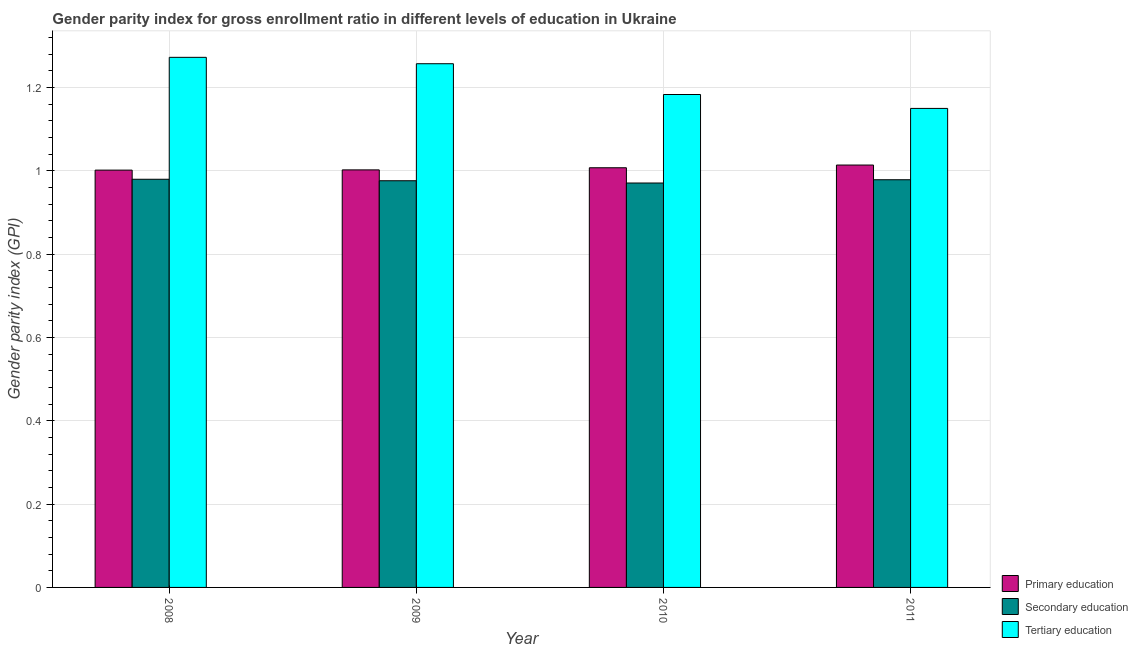How many groups of bars are there?
Your answer should be very brief. 4. Are the number of bars per tick equal to the number of legend labels?
Offer a very short reply. Yes. What is the label of the 2nd group of bars from the left?
Provide a succinct answer. 2009. In how many cases, is the number of bars for a given year not equal to the number of legend labels?
Offer a very short reply. 0. What is the gender parity index in primary education in 2009?
Give a very brief answer. 1. Across all years, what is the maximum gender parity index in secondary education?
Keep it short and to the point. 0.98. Across all years, what is the minimum gender parity index in secondary education?
Give a very brief answer. 0.97. What is the total gender parity index in secondary education in the graph?
Provide a succinct answer. 3.91. What is the difference between the gender parity index in primary education in 2009 and that in 2010?
Provide a succinct answer. -0.01. What is the difference between the gender parity index in secondary education in 2011 and the gender parity index in tertiary education in 2009?
Your answer should be compact. 0. What is the average gender parity index in primary education per year?
Make the answer very short. 1.01. In how many years, is the gender parity index in primary education greater than 1.2400000000000002?
Offer a very short reply. 0. What is the ratio of the gender parity index in primary education in 2008 to that in 2009?
Your answer should be compact. 1. Is the difference between the gender parity index in tertiary education in 2009 and 2010 greater than the difference between the gender parity index in primary education in 2009 and 2010?
Provide a succinct answer. No. What is the difference between the highest and the second highest gender parity index in tertiary education?
Give a very brief answer. 0.02. What is the difference between the highest and the lowest gender parity index in tertiary education?
Offer a very short reply. 0.12. In how many years, is the gender parity index in secondary education greater than the average gender parity index in secondary education taken over all years?
Make the answer very short. 2. Is the sum of the gender parity index in secondary education in 2008 and 2011 greater than the maximum gender parity index in tertiary education across all years?
Offer a very short reply. Yes. What does the 2nd bar from the left in 2008 represents?
Offer a terse response. Secondary education. What does the 3rd bar from the right in 2011 represents?
Offer a terse response. Primary education. Is it the case that in every year, the sum of the gender parity index in primary education and gender parity index in secondary education is greater than the gender parity index in tertiary education?
Your answer should be very brief. Yes. How many bars are there?
Your answer should be very brief. 12. How many years are there in the graph?
Your response must be concise. 4. How many legend labels are there?
Give a very brief answer. 3. What is the title of the graph?
Ensure brevity in your answer.  Gender parity index for gross enrollment ratio in different levels of education in Ukraine. Does "Machinery" appear as one of the legend labels in the graph?
Give a very brief answer. No. What is the label or title of the Y-axis?
Offer a very short reply. Gender parity index (GPI). What is the Gender parity index (GPI) of Primary education in 2008?
Your answer should be very brief. 1. What is the Gender parity index (GPI) in Secondary education in 2008?
Provide a short and direct response. 0.98. What is the Gender parity index (GPI) of Tertiary education in 2008?
Your response must be concise. 1.27. What is the Gender parity index (GPI) of Primary education in 2009?
Make the answer very short. 1. What is the Gender parity index (GPI) of Secondary education in 2009?
Offer a very short reply. 0.98. What is the Gender parity index (GPI) in Tertiary education in 2009?
Make the answer very short. 1.26. What is the Gender parity index (GPI) in Primary education in 2010?
Make the answer very short. 1.01. What is the Gender parity index (GPI) of Secondary education in 2010?
Provide a succinct answer. 0.97. What is the Gender parity index (GPI) in Tertiary education in 2010?
Provide a succinct answer. 1.18. What is the Gender parity index (GPI) of Primary education in 2011?
Offer a very short reply. 1.01. What is the Gender parity index (GPI) of Secondary education in 2011?
Provide a short and direct response. 0.98. What is the Gender parity index (GPI) in Tertiary education in 2011?
Keep it short and to the point. 1.15. Across all years, what is the maximum Gender parity index (GPI) of Primary education?
Make the answer very short. 1.01. Across all years, what is the maximum Gender parity index (GPI) in Secondary education?
Keep it short and to the point. 0.98. Across all years, what is the maximum Gender parity index (GPI) of Tertiary education?
Keep it short and to the point. 1.27. Across all years, what is the minimum Gender parity index (GPI) in Primary education?
Offer a very short reply. 1. Across all years, what is the minimum Gender parity index (GPI) of Secondary education?
Provide a short and direct response. 0.97. Across all years, what is the minimum Gender parity index (GPI) in Tertiary education?
Ensure brevity in your answer.  1.15. What is the total Gender parity index (GPI) in Primary education in the graph?
Keep it short and to the point. 4.03. What is the total Gender parity index (GPI) in Secondary education in the graph?
Offer a terse response. 3.91. What is the total Gender parity index (GPI) in Tertiary education in the graph?
Ensure brevity in your answer.  4.86. What is the difference between the Gender parity index (GPI) of Primary education in 2008 and that in 2009?
Offer a terse response. -0. What is the difference between the Gender parity index (GPI) of Secondary education in 2008 and that in 2009?
Your answer should be compact. 0. What is the difference between the Gender parity index (GPI) of Tertiary education in 2008 and that in 2009?
Ensure brevity in your answer.  0.02. What is the difference between the Gender parity index (GPI) of Primary education in 2008 and that in 2010?
Keep it short and to the point. -0.01. What is the difference between the Gender parity index (GPI) in Secondary education in 2008 and that in 2010?
Provide a succinct answer. 0.01. What is the difference between the Gender parity index (GPI) in Tertiary education in 2008 and that in 2010?
Make the answer very short. 0.09. What is the difference between the Gender parity index (GPI) of Primary education in 2008 and that in 2011?
Your response must be concise. -0.01. What is the difference between the Gender parity index (GPI) of Secondary education in 2008 and that in 2011?
Offer a terse response. 0. What is the difference between the Gender parity index (GPI) in Tertiary education in 2008 and that in 2011?
Provide a succinct answer. 0.12. What is the difference between the Gender parity index (GPI) in Primary education in 2009 and that in 2010?
Provide a short and direct response. -0.01. What is the difference between the Gender parity index (GPI) in Secondary education in 2009 and that in 2010?
Your answer should be compact. 0.01. What is the difference between the Gender parity index (GPI) of Tertiary education in 2009 and that in 2010?
Offer a very short reply. 0.07. What is the difference between the Gender parity index (GPI) in Primary education in 2009 and that in 2011?
Provide a short and direct response. -0.01. What is the difference between the Gender parity index (GPI) in Secondary education in 2009 and that in 2011?
Offer a terse response. -0. What is the difference between the Gender parity index (GPI) in Tertiary education in 2009 and that in 2011?
Your response must be concise. 0.11. What is the difference between the Gender parity index (GPI) of Primary education in 2010 and that in 2011?
Your answer should be very brief. -0.01. What is the difference between the Gender parity index (GPI) in Secondary education in 2010 and that in 2011?
Keep it short and to the point. -0.01. What is the difference between the Gender parity index (GPI) in Tertiary education in 2010 and that in 2011?
Provide a succinct answer. 0.03. What is the difference between the Gender parity index (GPI) of Primary education in 2008 and the Gender parity index (GPI) of Secondary education in 2009?
Provide a succinct answer. 0.03. What is the difference between the Gender parity index (GPI) in Primary education in 2008 and the Gender parity index (GPI) in Tertiary education in 2009?
Give a very brief answer. -0.26. What is the difference between the Gender parity index (GPI) of Secondary education in 2008 and the Gender parity index (GPI) of Tertiary education in 2009?
Ensure brevity in your answer.  -0.28. What is the difference between the Gender parity index (GPI) in Primary education in 2008 and the Gender parity index (GPI) in Secondary education in 2010?
Give a very brief answer. 0.03. What is the difference between the Gender parity index (GPI) of Primary education in 2008 and the Gender parity index (GPI) of Tertiary education in 2010?
Offer a very short reply. -0.18. What is the difference between the Gender parity index (GPI) of Secondary education in 2008 and the Gender parity index (GPI) of Tertiary education in 2010?
Your response must be concise. -0.2. What is the difference between the Gender parity index (GPI) of Primary education in 2008 and the Gender parity index (GPI) of Secondary education in 2011?
Your answer should be compact. 0.02. What is the difference between the Gender parity index (GPI) in Primary education in 2008 and the Gender parity index (GPI) in Tertiary education in 2011?
Your response must be concise. -0.15. What is the difference between the Gender parity index (GPI) in Secondary education in 2008 and the Gender parity index (GPI) in Tertiary education in 2011?
Provide a short and direct response. -0.17. What is the difference between the Gender parity index (GPI) of Primary education in 2009 and the Gender parity index (GPI) of Secondary education in 2010?
Ensure brevity in your answer.  0.03. What is the difference between the Gender parity index (GPI) in Primary education in 2009 and the Gender parity index (GPI) in Tertiary education in 2010?
Make the answer very short. -0.18. What is the difference between the Gender parity index (GPI) of Secondary education in 2009 and the Gender parity index (GPI) of Tertiary education in 2010?
Make the answer very short. -0.21. What is the difference between the Gender parity index (GPI) of Primary education in 2009 and the Gender parity index (GPI) of Secondary education in 2011?
Offer a very short reply. 0.02. What is the difference between the Gender parity index (GPI) in Primary education in 2009 and the Gender parity index (GPI) in Tertiary education in 2011?
Your answer should be compact. -0.15. What is the difference between the Gender parity index (GPI) in Secondary education in 2009 and the Gender parity index (GPI) in Tertiary education in 2011?
Provide a succinct answer. -0.17. What is the difference between the Gender parity index (GPI) of Primary education in 2010 and the Gender parity index (GPI) of Secondary education in 2011?
Provide a succinct answer. 0.03. What is the difference between the Gender parity index (GPI) of Primary education in 2010 and the Gender parity index (GPI) of Tertiary education in 2011?
Provide a succinct answer. -0.14. What is the difference between the Gender parity index (GPI) in Secondary education in 2010 and the Gender parity index (GPI) in Tertiary education in 2011?
Offer a terse response. -0.18. What is the average Gender parity index (GPI) in Primary education per year?
Your answer should be compact. 1.01. What is the average Gender parity index (GPI) of Secondary education per year?
Your answer should be very brief. 0.98. What is the average Gender parity index (GPI) of Tertiary education per year?
Provide a short and direct response. 1.22. In the year 2008, what is the difference between the Gender parity index (GPI) in Primary education and Gender parity index (GPI) in Secondary education?
Provide a short and direct response. 0.02. In the year 2008, what is the difference between the Gender parity index (GPI) of Primary education and Gender parity index (GPI) of Tertiary education?
Keep it short and to the point. -0.27. In the year 2008, what is the difference between the Gender parity index (GPI) in Secondary education and Gender parity index (GPI) in Tertiary education?
Give a very brief answer. -0.29. In the year 2009, what is the difference between the Gender parity index (GPI) of Primary education and Gender parity index (GPI) of Secondary education?
Offer a very short reply. 0.03. In the year 2009, what is the difference between the Gender parity index (GPI) in Primary education and Gender parity index (GPI) in Tertiary education?
Your answer should be very brief. -0.25. In the year 2009, what is the difference between the Gender parity index (GPI) of Secondary education and Gender parity index (GPI) of Tertiary education?
Offer a terse response. -0.28. In the year 2010, what is the difference between the Gender parity index (GPI) of Primary education and Gender parity index (GPI) of Secondary education?
Your response must be concise. 0.04. In the year 2010, what is the difference between the Gender parity index (GPI) in Primary education and Gender parity index (GPI) in Tertiary education?
Make the answer very short. -0.18. In the year 2010, what is the difference between the Gender parity index (GPI) of Secondary education and Gender parity index (GPI) of Tertiary education?
Keep it short and to the point. -0.21. In the year 2011, what is the difference between the Gender parity index (GPI) of Primary education and Gender parity index (GPI) of Secondary education?
Keep it short and to the point. 0.04. In the year 2011, what is the difference between the Gender parity index (GPI) of Primary education and Gender parity index (GPI) of Tertiary education?
Offer a terse response. -0.14. In the year 2011, what is the difference between the Gender parity index (GPI) of Secondary education and Gender parity index (GPI) of Tertiary education?
Provide a short and direct response. -0.17. What is the ratio of the Gender parity index (GPI) of Secondary education in 2008 to that in 2009?
Your response must be concise. 1. What is the ratio of the Gender parity index (GPI) in Tertiary education in 2008 to that in 2009?
Provide a short and direct response. 1.01. What is the ratio of the Gender parity index (GPI) of Secondary education in 2008 to that in 2010?
Provide a succinct answer. 1.01. What is the ratio of the Gender parity index (GPI) of Tertiary education in 2008 to that in 2010?
Give a very brief answer. 1.08. What is the ratio of the Gender parity index (GPI) of Secondary education in 2008 to that in 2011?
Make the answer very short. 1. What is the ratio of the Gender parity index (GPI) in Tertiary education in 2008 to that in 2011?
Provide a short and direct response. 1.11. What is the ratio of the Gender parity index (GPI) in Secondary education in 2009 to that in 2010?
Make the answer very short. 1.01. What is the ratio of the Gender parity index (GPI) of Tertiary education in 2009 to that in 2010?
Offer a terse response. 1.06. What is the ratio of the Gender parity index (GPI) in Primary education in 2009 to that in 2011?
Ensure brevity in your answer.  0.99. What is the ratio of the Gender parity index (GPI) of Tertiary education in 2009 to that in 2011?
Give a very brief answer. 1.09. What is the difference between the highest and the second highest Gender parity index (GPI) of Primary education?
Provide a short and direct response. 0.01. What is the difference between the highest and the second highest Gender parity index (GPI) in Secondary education?
Provide a succinct answer. 0. What is the difference between the highest and the second highest Gender parity index (GPI) in Tertiary education?
Offer a terse response. 0.02. What is the difference between the highest and the lowest Gender parity index (GPI) in Primary education?
Offer a terse response. 0.01. What is the difference between the highest and the lowest Gender parity index (GPI) in Secondary education?
Your response must be concise. 0.01. What is the difference between the highest and the lowest Gender parity index (GPI) in Tertiary education?
Your answer should be very brief. 0.12. 